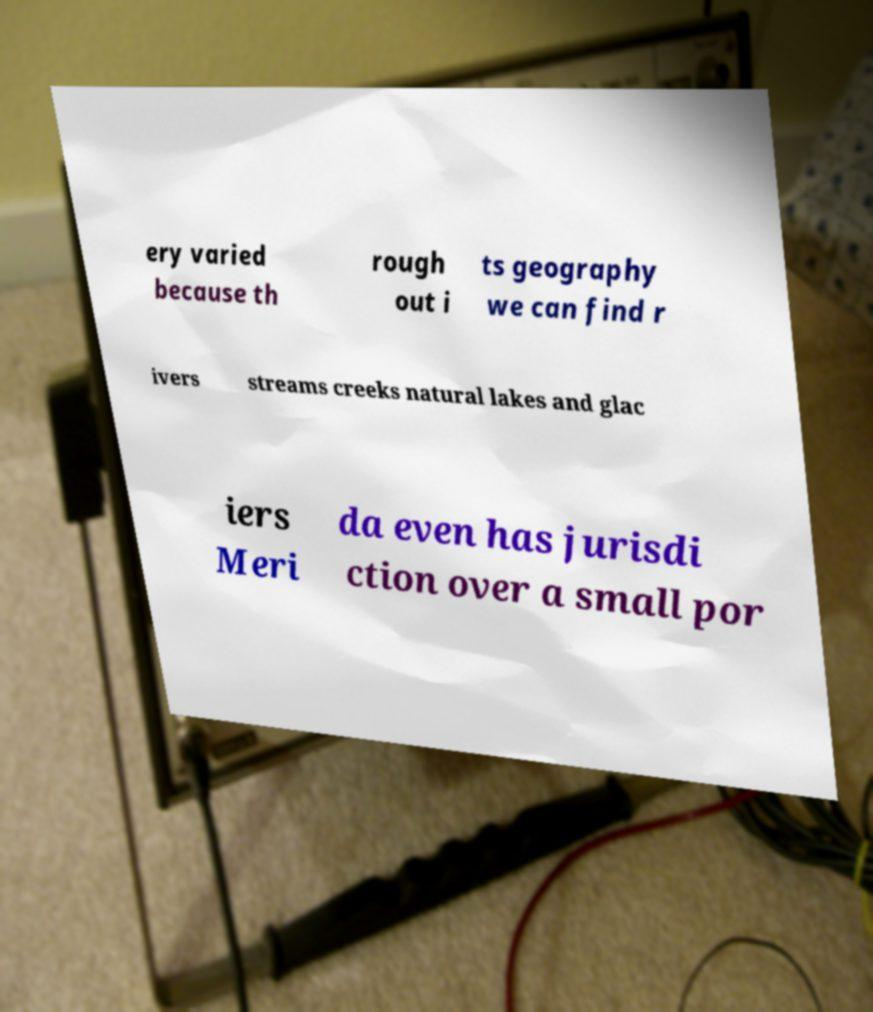For documentation purposes, I need the text within this image transcribed. Could you provide that? ery varied because th rough out i ts geography we can find r ivers streams creeks natural lakes and glac iers Meri da even has jurisdi ction over a small por 